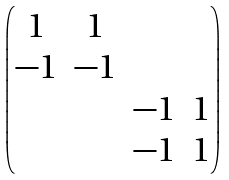<formula> <loc_0><loc_0><loc_500><loc_500>\begin{pmatrix} 1 & 1 \\ - 1 & - 1 \\ & & - 1 & 1 \\ & & - 1 & 1 \end{pmatrix}</formula> 